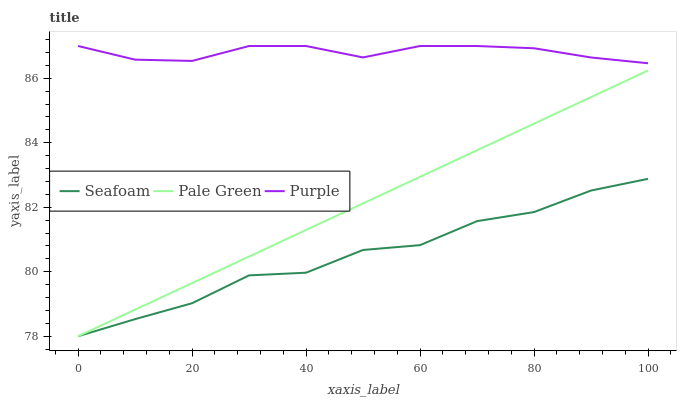Does Seafoam have the minimum area under the curve?
Answer yes or no. Yes. Does Pale Green have the minimum area under the curve?
Answer yes or no. No. Does Pale Green have the maximum area under the curve?
Answer yes or no. No. Is Seafoam the roughest?
Answer yes or no. Yes. Is Seafoam the smoothest?
Answer yes or no. No. Is Pale Green the roughest?
Answer yes or no. No. Does Pale Green have the highest value?
Answer yes or no. No. Is Pale Green less than Purple?
Answer yes or no. Yes. Is Purple greater than Pale Green?
Answer yes or no. Yes. Does Pale Green intersect Purple?
Answer yes or no. No. 